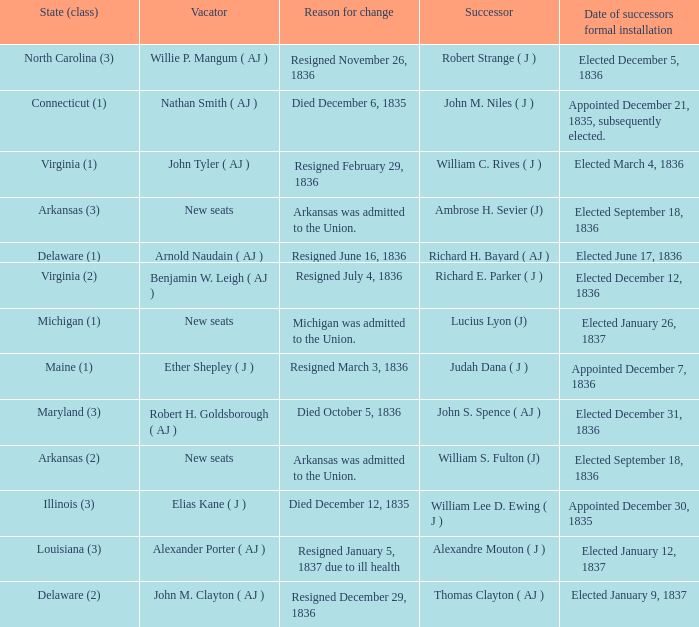Name the successor for elected january 26, 1837 1.0. 